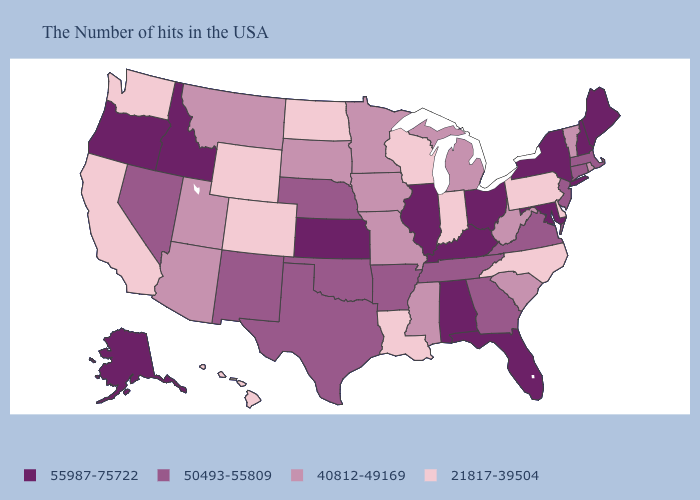Name the states that have a value in the range 21817-39504?
Concise answer only. Delaware, Pennsylvania, North Carolina, Indiana, Wisconsin, Louisiana, North Dakota, Wyoming, Colorado, California, Washington, Hawaii. What is the value of North Carolina?
Be succinct. 21817-39504. Name the states that have a value in the range 21817-39504?
Keep it brief. Delaware, Pennsylvania, North Carolina, Indiana, Wisconsin, Louisiana, North Dakota, Wyoming, Colorado, California, Washington, Hawaii. Name the states that have a value in the range 21817-39504?
Write a very short answer. Delaware, Pennsylvania, North Carolina, Indiana, Wisconsin, Louisiana, North Dakota, Wyoming, Colorado, California, Washington, Hawaii. Name the states that have a value in the range 55987-75722?
Concise answer only. Maine, New Hampshire, New York, Maryland, Ohio, Florida, Kentucky, Alabama, Illinois, Kansas, Idaho, Oregon, Alaska. What is the highest value in the Northeast ?
Short answer required. 55987-75722. How many symbols are there in the legend?
Write a very short answer. 4. What is the highest value in states that border Oklahoma?
Concise answer only. 55987-75722. Name the states that have a value in the range 21817-39504?
Write a very short answer. Delaware, Pennsylvania, North Carolina, Indiana, Wisconsin, Louisiana, North Dakota, Wyoming, Colorado, California, Washington, Hawaii. Among the states that border Georgia , which have the lowest value?
Short answer required. North Carolina. Does Wisconsin have the lowest value in the MidWest?
Be succinct. Yes. Does Maine have the highest value in the USA?
Quick response, please. Yes. Name the states that have a value in the range 21817-39504?
Answer briefly. Delaware, Pennsylvania, North Carolina, Indiana, Wisconsin, Louisiana, North Dakota, Wyoming, Colorado, California, Washington, Hawaii. What is the value of North Carolina?
Answer briefly. 21817-39504. 